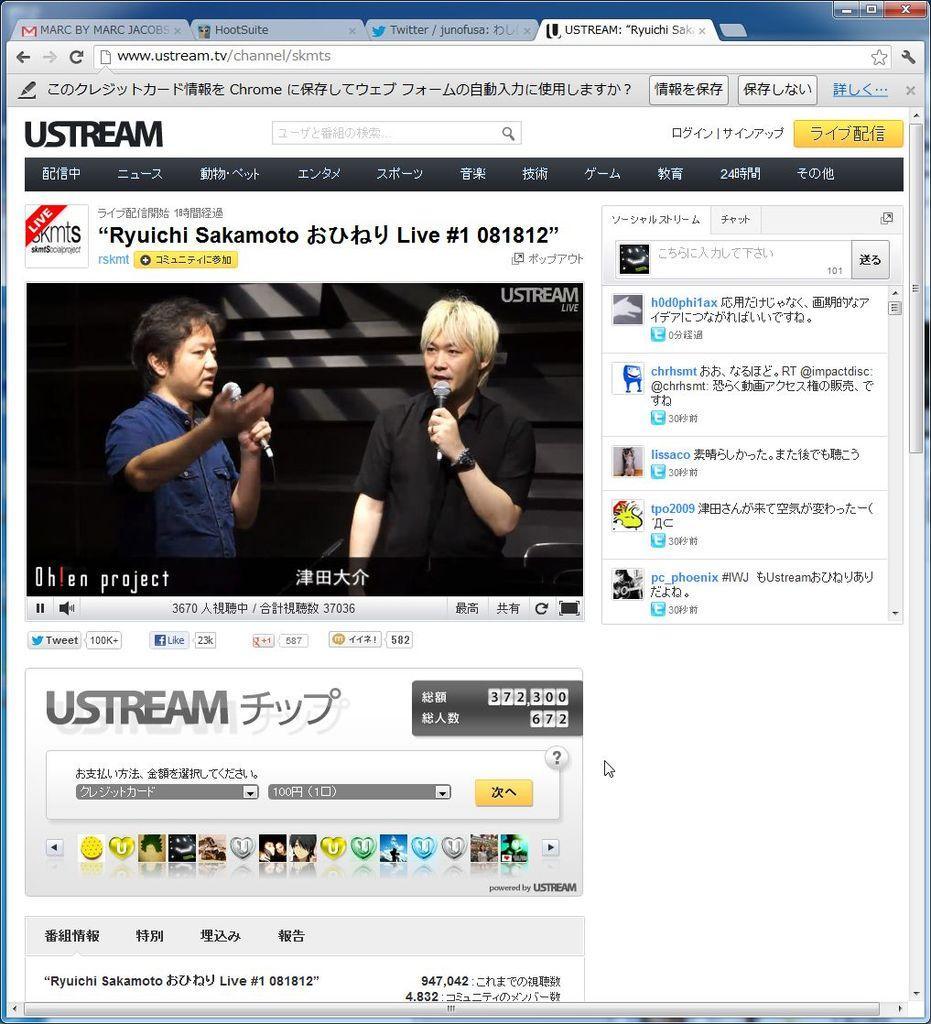In one or two sentences, can you explain what this image depicts? In this picture which can see a screenshot of the computer screen. On the left there is a man who is wearing blue shirt and holding a mic. Beside him we can see another man who is wearing black shirt and watch. He is also holding a mic. 